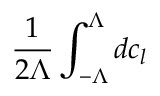<formula> <loc_0><loc_0><loc_500><loc_500>\frac { 1 } { 2 \Lambda } \int _ { - \Lambda } ^ { \Lambda } d c _ { l }</formula> 